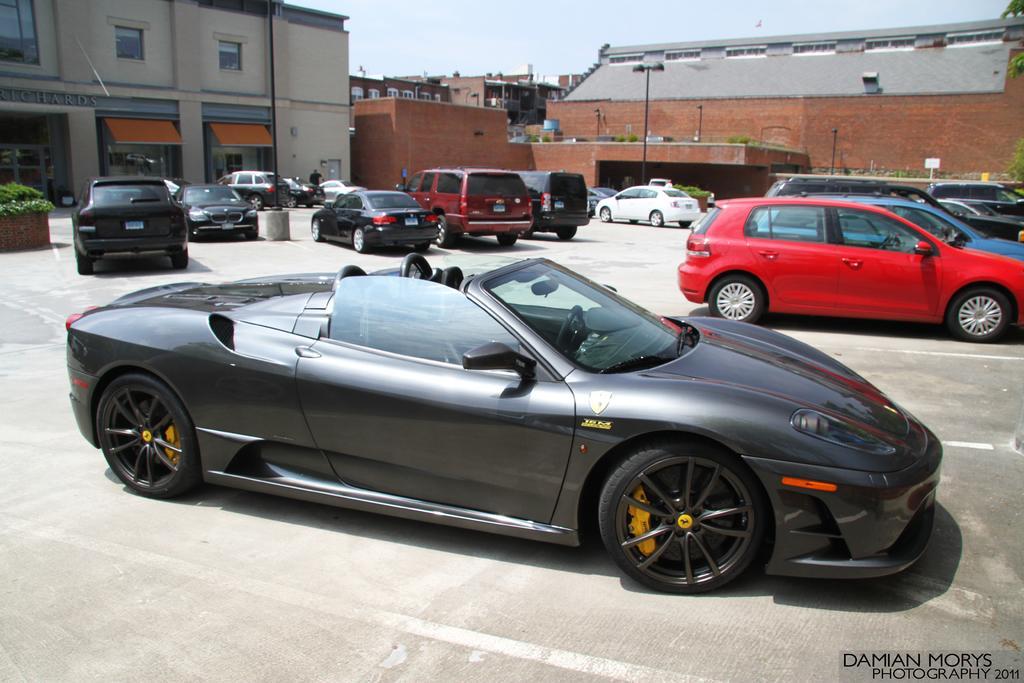How would you summarize this image in a sentence or two? In this picture I can see few cars and I can see buildings and I can see a tree and few plants and few lights to the pole and I can see a cloudy sky and looks like a human standing and I can see text at the bottom right corner of the picture. 